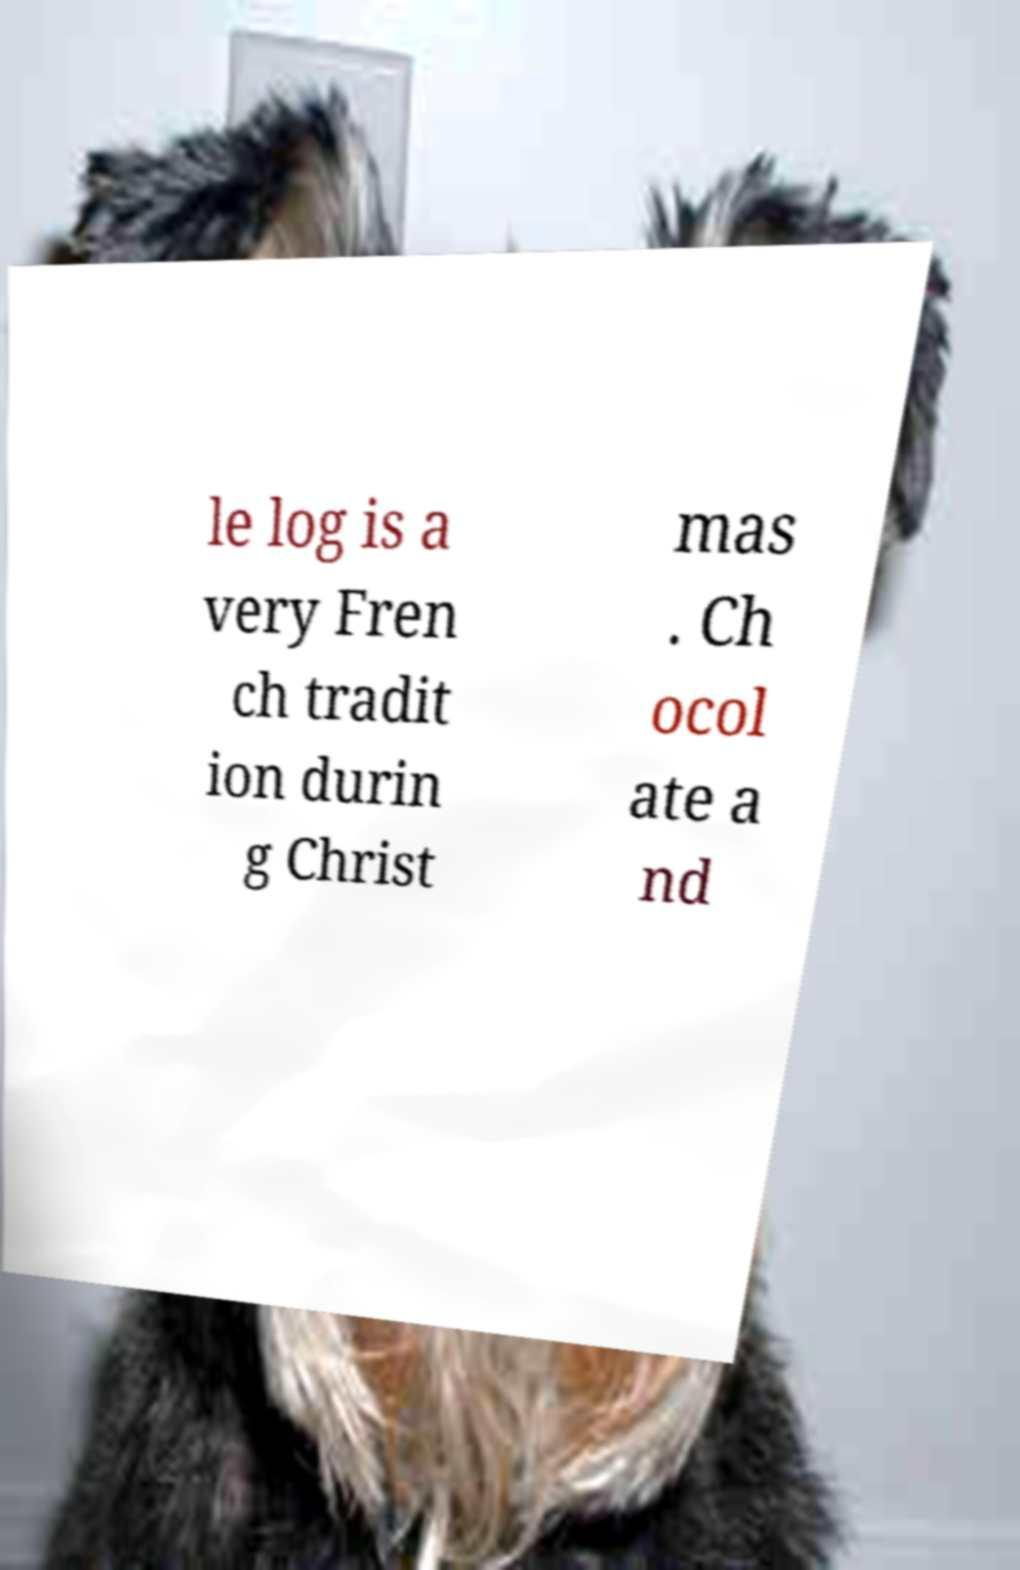Could you extract and type out the text from this image? le log is a very Fren ch tradit ion durin g Christ mas . Ch ocol ate a nd 